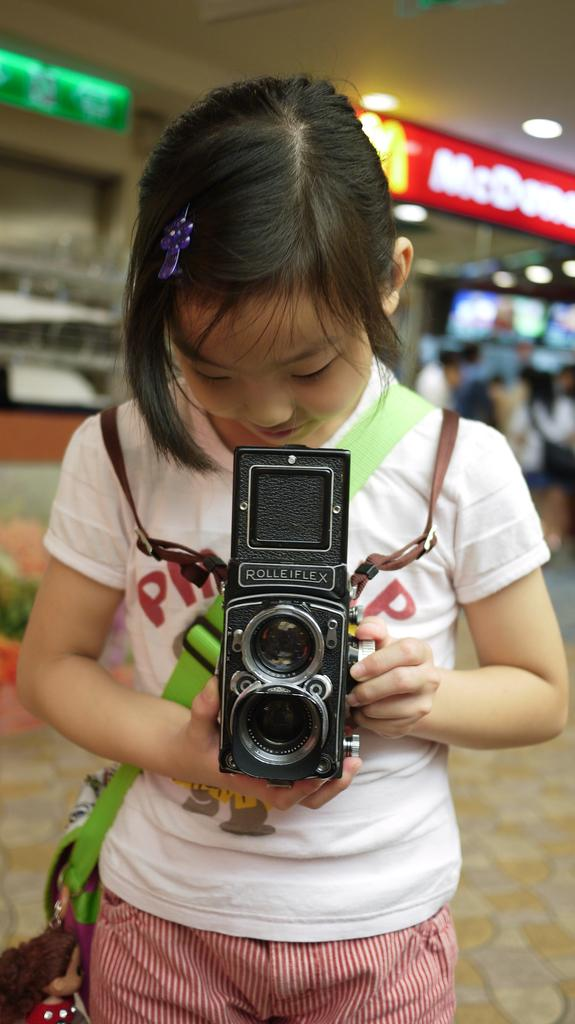Who is the main subject in the image? There is a girl in the image. What is the girl doing in the image? The girl is standing in the image. What is the girl holding in the image? The girl is holding a camera in the image. What is the girl wearing in the image? The girl is wearing a white t-shirt in the image. How many visitors are present in the image? There is no mention of visitors in the image; it only features a girl. Is there a bike visible in the image? There is no bike present in the image. 